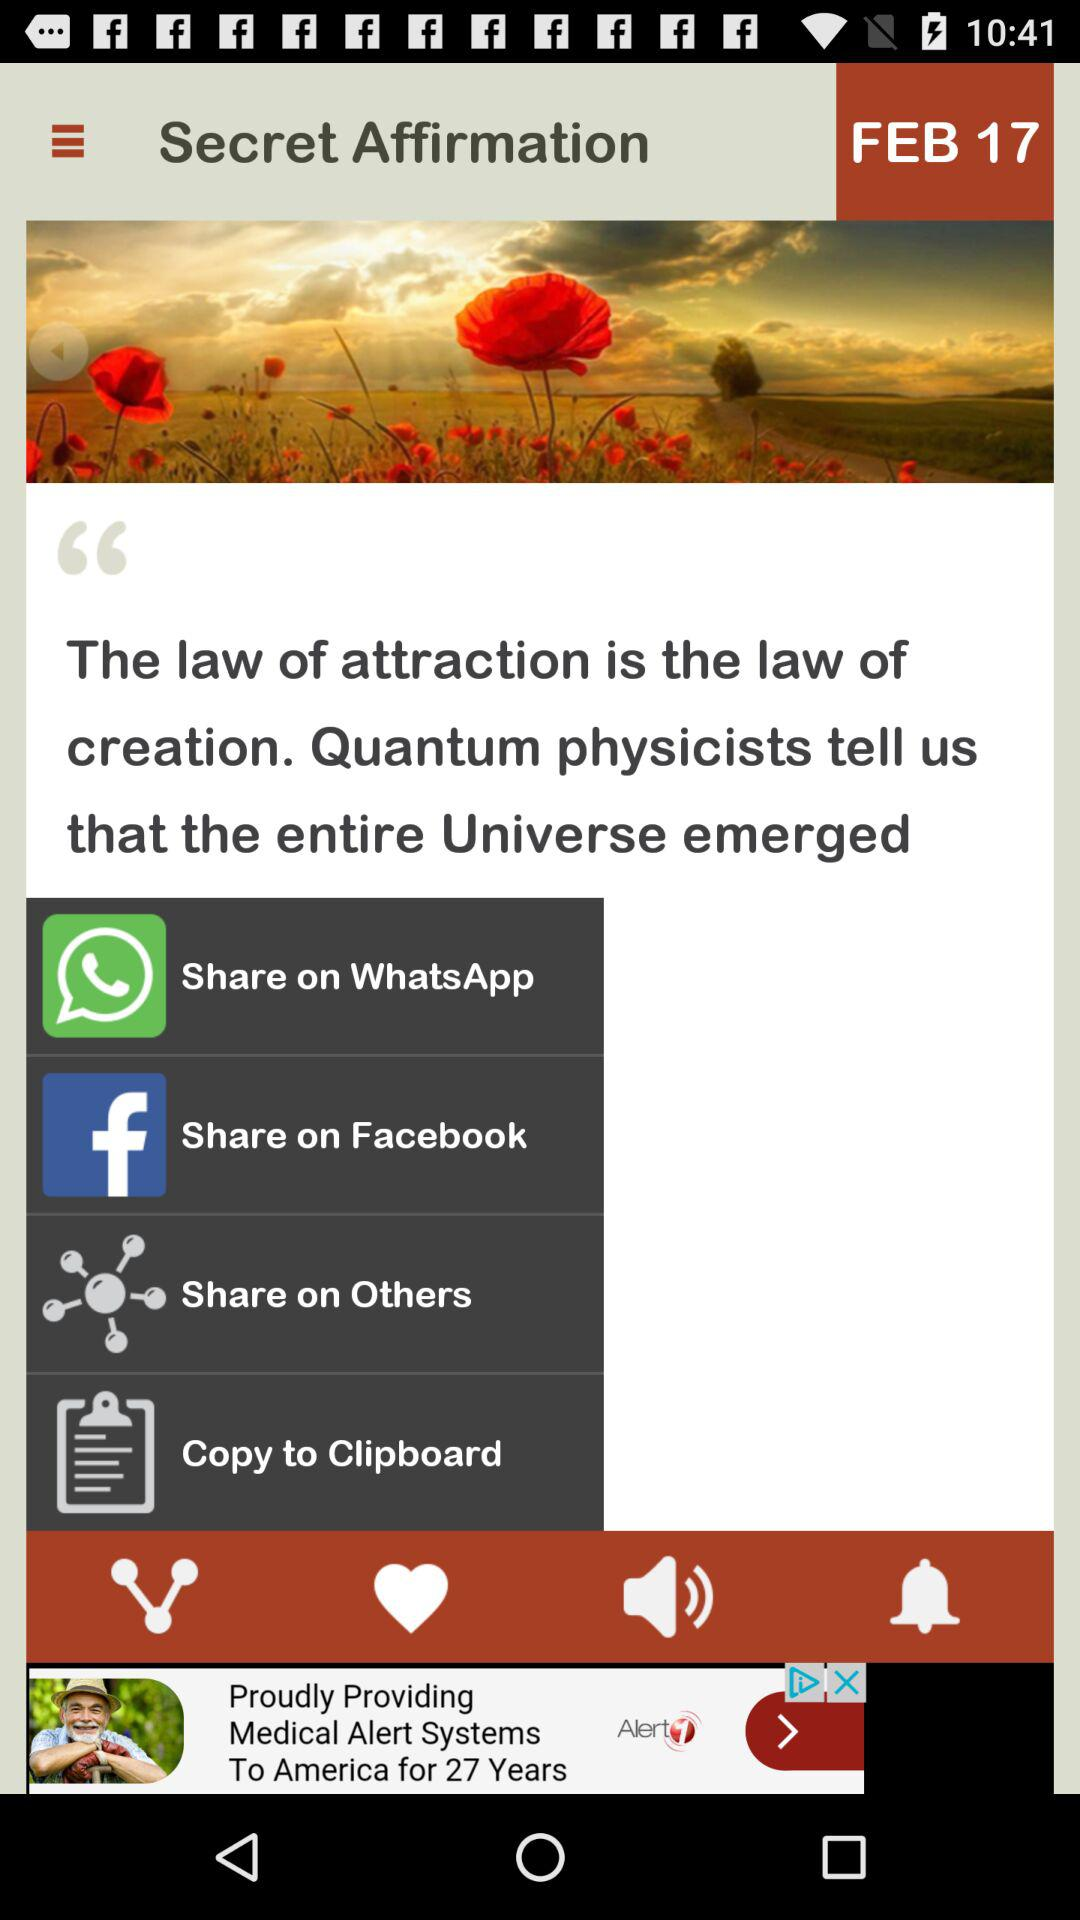What is the mentioned date? The mentioned date is February 17. 